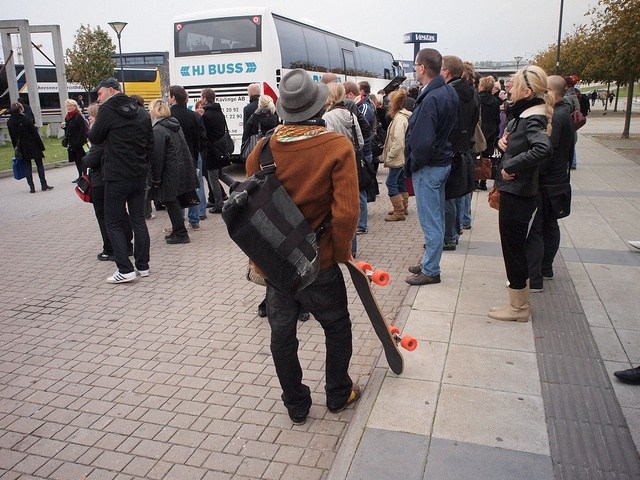Describe the objects in this image and their specific colors. I can see people in lightgray, black, maroon, brown, and gray tones, bus in lightgray, darkgray, black, and gray tones, people in lightgray, black, gray, and darkgray tones, people in lightgray, black, gray, and tan tones, and people in lightgray, black, gray, and darkgray tones in this image. 